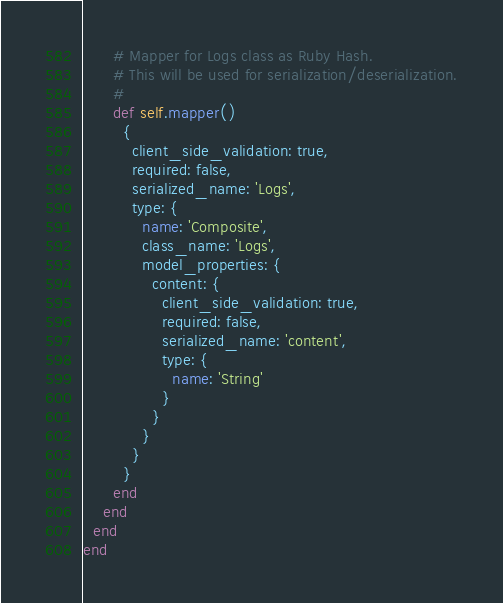Convert code to text. <code><loc_0><loc_0><loc_500><loc_500><_Ruby_>      # Mapper for Logs class as Ruby Hash.
      # This will be used for serialization/deserialization.
      #
      def self.mapper()
        {
          client_side_validation: true,
          required: false,
          serialized_name: 'Logs',
          type: {
            name: 'Composite',
            class_name: 'Logs',
            model_properties: {
              content: {
                client_side_validation: true,
                required: false,
                serialized_name: 'content',
                type: {
                  name: 'String'
                }
              }
            }
          }
        }
      end
    end
  end
end
</code> 